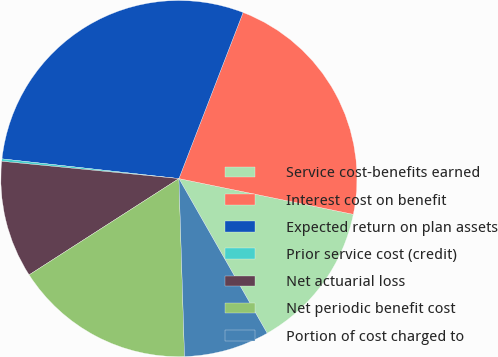Convert chart. <chart><loc_0><loc_0><loc_500><loc_500><pie_chart><fcel>Service cost-benefits earned<fcel>Interest cost on benefit<fcel>Expected return on plan assets<fcel>Prior service cost (credit)<fcel>Net actuarial loss<fcel>Net periodic benefit cost<fcel>Portion of cost charged to<nl><fcel>13.53%<fcel>22.35%<fcel>29.1%<fcel>0.22%<fcel>10.64%<fcel>16.41%<fcel>7.75%<nl></chart> 